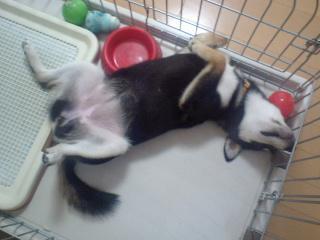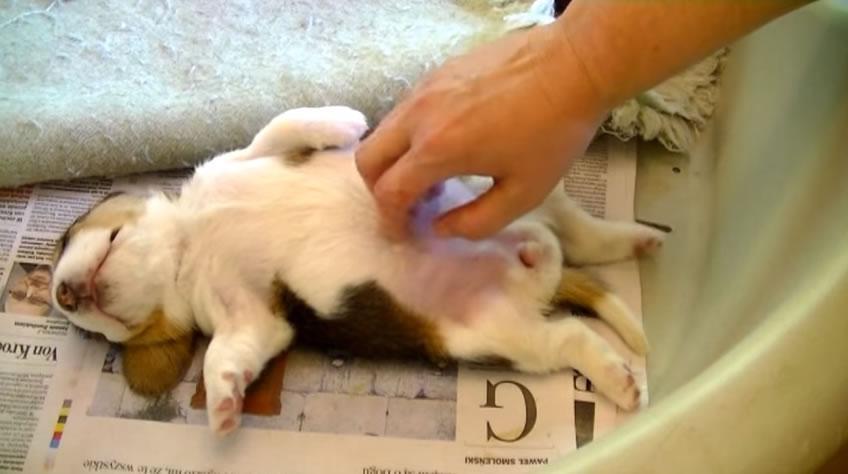The first image is the image on the left, the second image is the image on the right. Considering the images on both sides, is "All dogs' stomachs are visible." valid? Answer yes or no. Yes. 